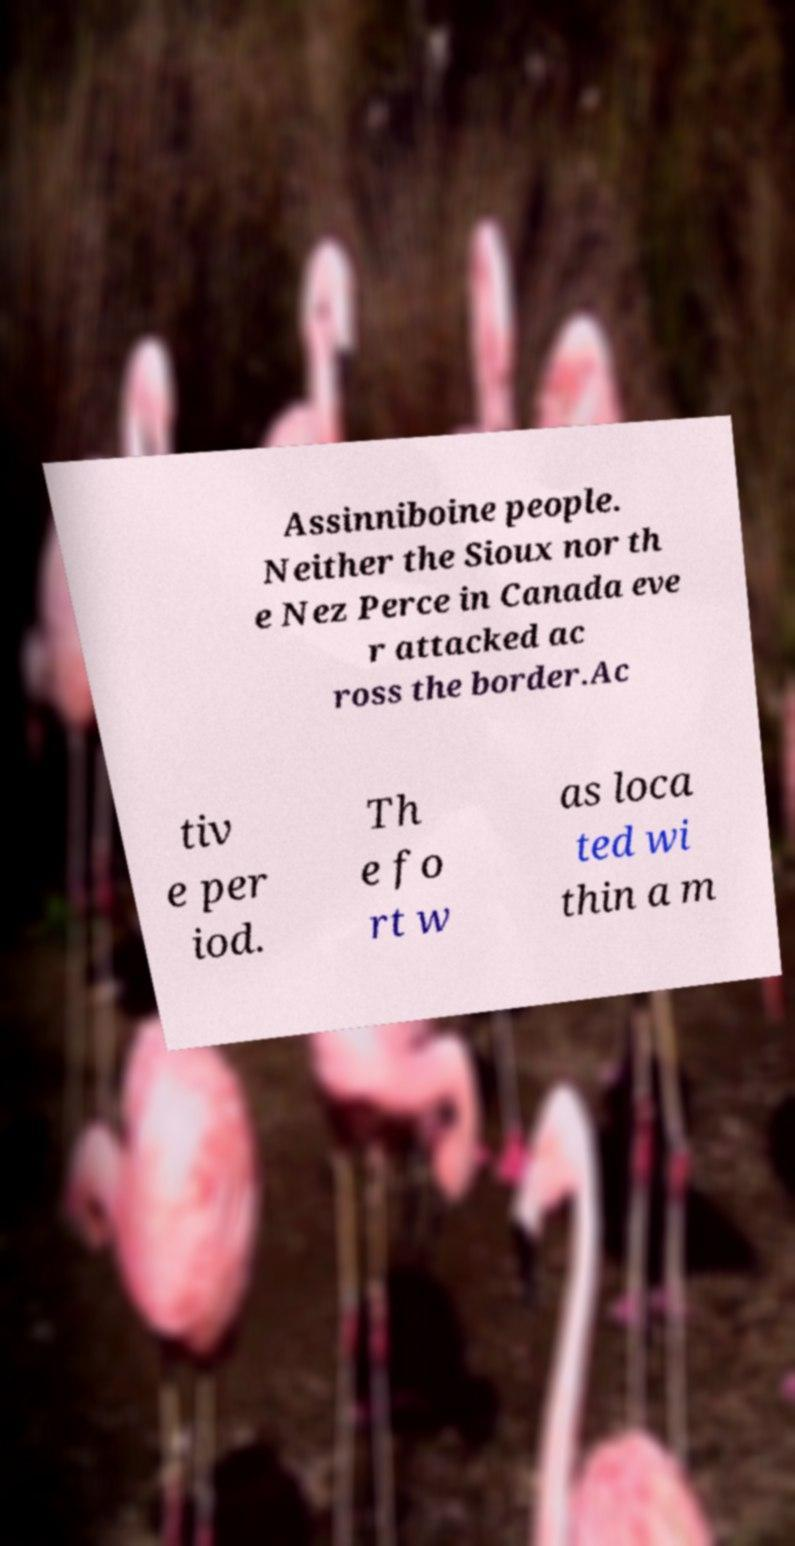What messages or text are displayed in this image? I need them in a readable, typed format. Assinniboine people. Neither the Sioux nor th e Nez Perce in Canada eve r attacked ac ross the border.Ac tiv e per iod. Th e fo rt w as loca ted wi thin a m 